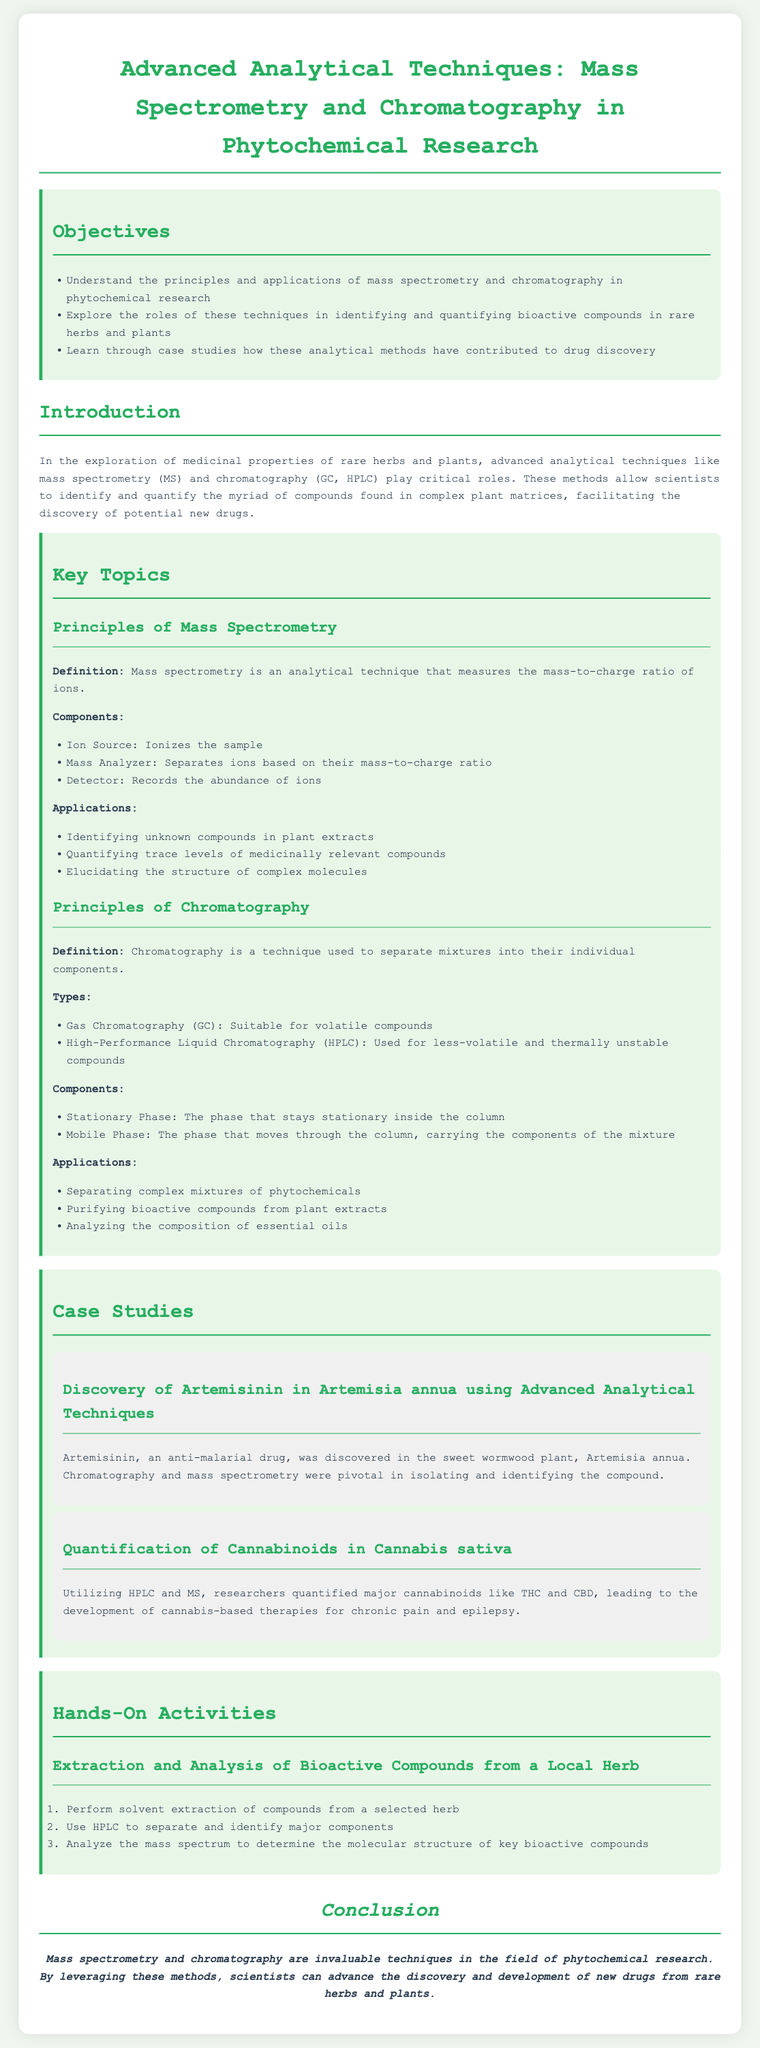What are the objectives of the lesson? The objectives are outlined in a section specifically discussing them, including understanding principles, exploring roles, and learning through case studies.
Answer: Understand the principles and applications of mass spectrometry and chromatography in phytochemical research What is mass spectrometry primarily used for? The document lists applications of mass spectrometry, emphasizing its role in identifying unknown compounds and quantifying trace levels.
Answer: Identifying unknown compounds in plant extracts What types of chromatography are mentioned? The document specifically lists the types of chromatography relevant to the lesson.
Answer: Gas Chromatography and High-Performance Liquid Chromatography What was discovered in Artemisia annua? The case study mentions a specific compound that was pivotal in drug discovery.
Answer: Artemisinin What is the role of the stationary phase in chromatography? The document defines components of chromatography, specifying the role of the stationary phase.
Answer: The phase that stays stationary inside the column What are the hands-on activities included in the lesson? The activities section outlines specific tasks involved in the extraction and analysis process.
Answer: Extraction and Analysis of Bioactive Compounds from a Local Herb How does chromatography contribute to drug discovery? The document explains chromatography's application in separating mixtures and purifying bioactive compounds, which are essential for drug development.
Answer: Separating complex mixtures of phytochemicals What is the main conclusion of the lesson? The conclusion summarizes the importance of the techniques discussed in phytochemical research.
Answer: Mass spectrometry and chromatography are invaluable techniques in the field of phytochemical research 